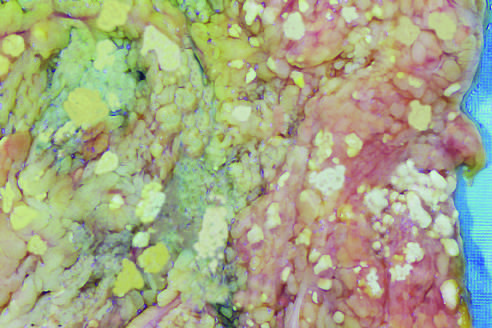what represent foci of fat necrosis with calcium soap formation at sites of lipid breakdown in the mesentery?
Answer the question using a single word or phrase. The areas of white chalky deposits 